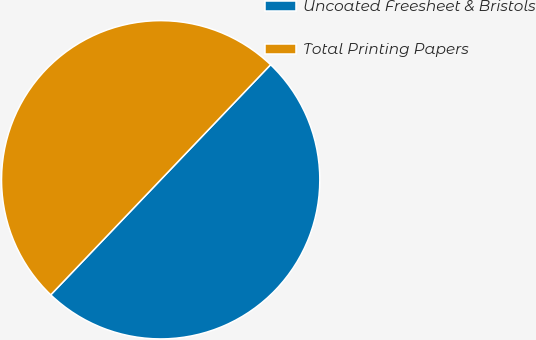Convert chart to OTSL. <chart><loc_0><loc_0><loc_500><loc_500><pie_chart><fcel>Uncoated Freesheet & Bristols<fcel>Total Printing Papers<nl><fcel>50.0%<fcel>50.0%<nl></chart> 